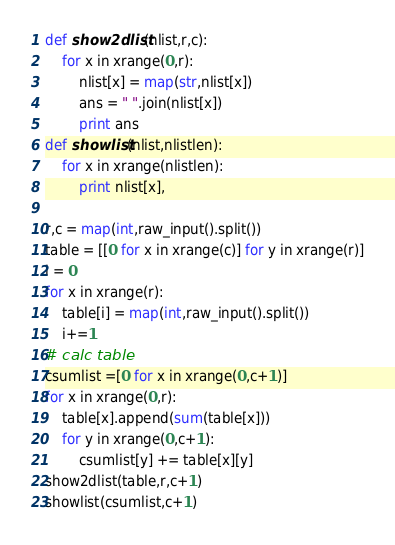Convert code to text. <code><loc_0><loc_0><loc_500><loc_500><_Python_>def show2dlist(nlist,r,c):
    for x in xrange(0,r):
        nlist[x] = map(str,nlist[x])
        ans = " ".join(nlist[x])
        print ans
def showlist(nlist,nlistlen):
    for x in xrange(nlistlen):
        print nlist[x],

r,c = map(int,raw_input().split())
table = [[0 for x in xrange(c)] for y in xrange(r)]
i = 0
for x in xrange(r):
    table[i] = map(int,raw_input().split())
    i+=1
# calc table
csumlist =[0 for x in xrange(0,c+1)]
for x in xrange(0,r):
    table[x].append(sum(table[x]))
    for y in xrange(0,c+1):
        csumlist[y] += table[x][y]
show2dlist(table,r,c+1)
showlist(csumlist,c+1)</code> 